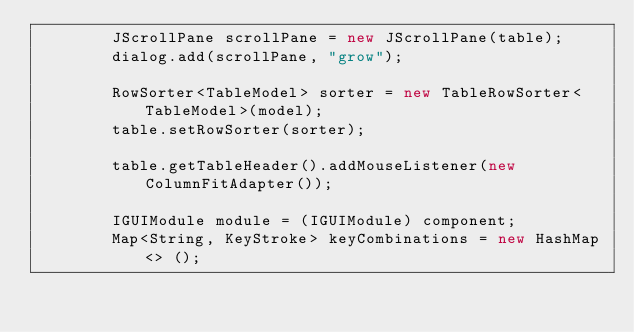<code> <loc_0><loc_0><loc_500><loc_500><_Java_>        JScrollPane scrollPane = new JScrollPane(table);
        dialog.add(scrollPane, "grow");

        RowSorter<TableModel> sorter = new TableRowSorter<TableModel>(model);
        table.setRowSorter(sorter);

        table.getTableHeader().addMouseListener(new ColumnFitAdapter());

        IGUIModule module = (IGUIModule) component;
        Map<String, KeyStroke> keyCombinations = new HashMap<> ();</code> 